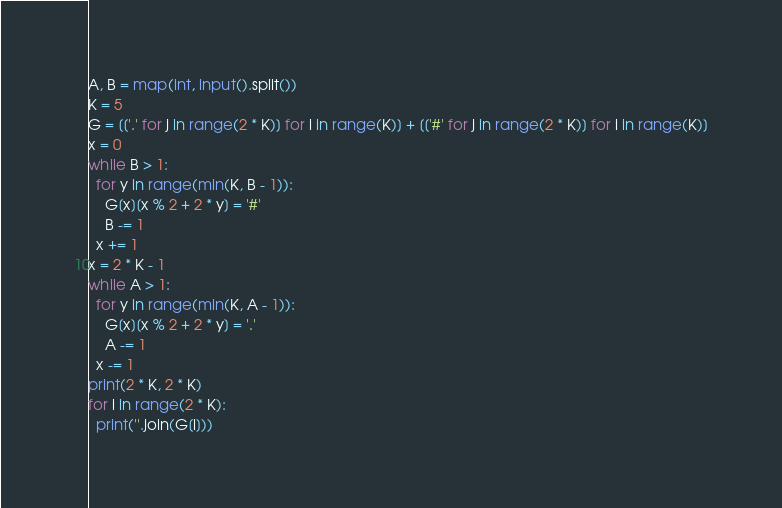Convert code to text. <code><loc_0><loc_0><loc_500><loc_500><_Python_>A, B = map(int, input().split())
K = 5
G = [['.' for j in range(2 * K)] for i in range(K)] + [['#' for j in range(2 * K)] for i in range(K)]
x = 0
while B > 1:
  for y in range(min(K, B - 1)):
    G[x][x % 2 + 2 * y] = '#'
    B -= 1
  x += 1
x = 2 * K - 1
while A > 1:
  for y in range(min(K, A - 1)):
    G[x][x % 2 + 2 * y] = '.'
    A -= 1
  x -= 1
print(2 * K, 2 * K)
for i in range(2 * K):
  print(''.join(G[i]))</code> 